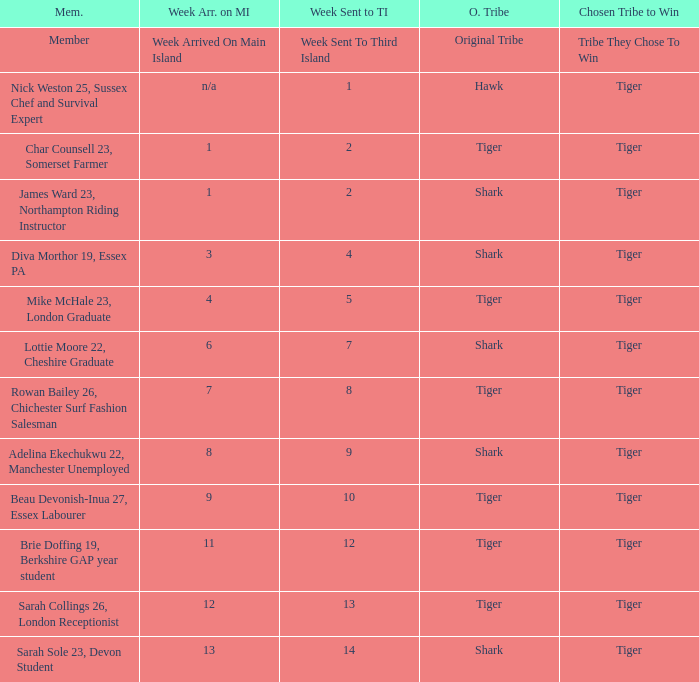What week was the member who arrived on the main island in week 6 sent to the third island? 7.0. 